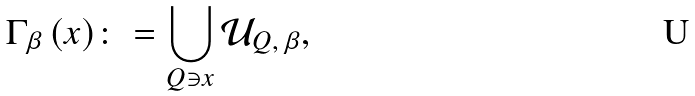Convert formula to latex. <formula><loc_0><loc_0><loc_500><loc_500>\Gamma _ { \beta } \, ( x ) \colon = \bigcup _ { Q \ni x } \mathcal { U } _ { Q , \, \beta } ,</formula> 